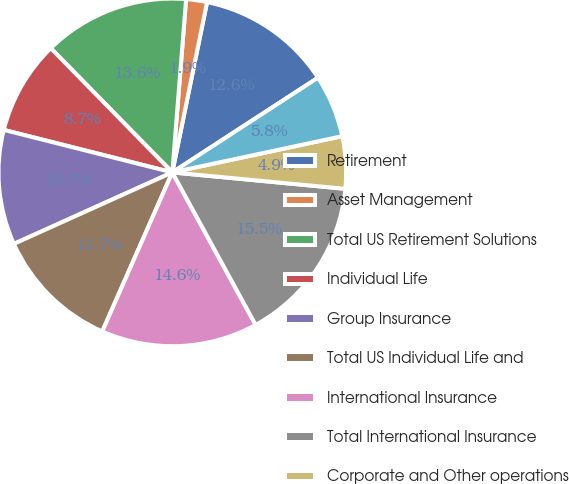Convert chart. <chart><loc_0><loc_0><loc_500><loc_500><pie_chart><fcel>Retirement<fcel>Asset Management<fcel>Total US Retirement Solutions<fcel>Individual Life<fcel>Group Insurance<fcel>Total US Individual Life and<fcel>International Insurance<fcel>Total International Insurance<fcel>Corporate and Other operations<fcel>Total Corporate and Other<nl><fcel>12.62%<fcel>1.94%<fcel>13.59%<fcel>8.74%<fcel>10.68%<fcel>11.65%<fcel>14.56%<fcel>15.53%<fcel>4.85%<fcel>5.83%<nl></chart> 